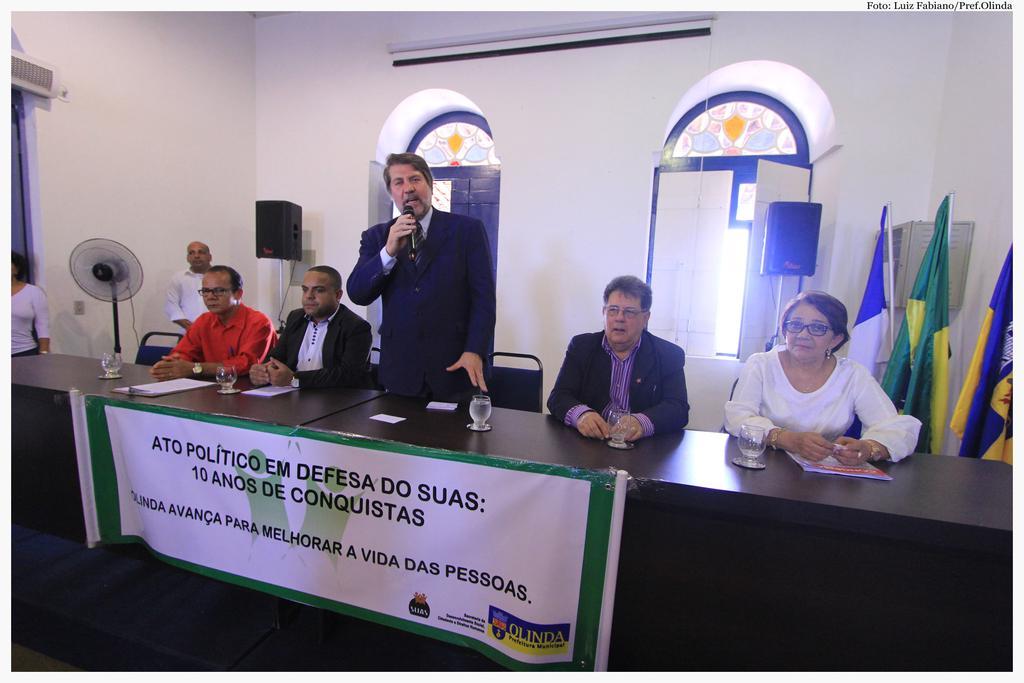In one or two sentences, can you explain what this image depicts? In this image we can see the people sitting on the chairs in front of the table. On the table we can see the glasses, papers and we can also see the banner. There is a man standing and holding the mike. On the left we can see two persons standing. Image also consists of a table fan, sound boxes, windows, flags, wall. 